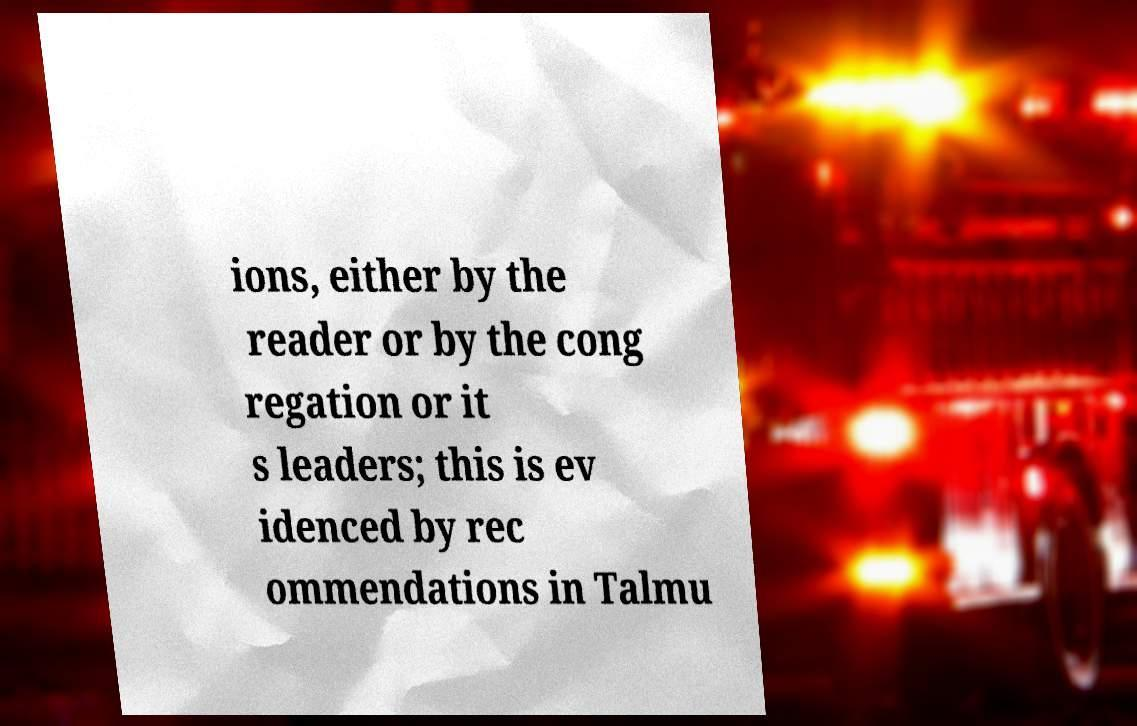Can you read and provide the text displayed in the image?This photo seems to have some interesting text. Can you extract and type it out for me? ions, either by the reader or by the cong regation or it s leaders; this is ev idenced by rec ommendations in Talmu 